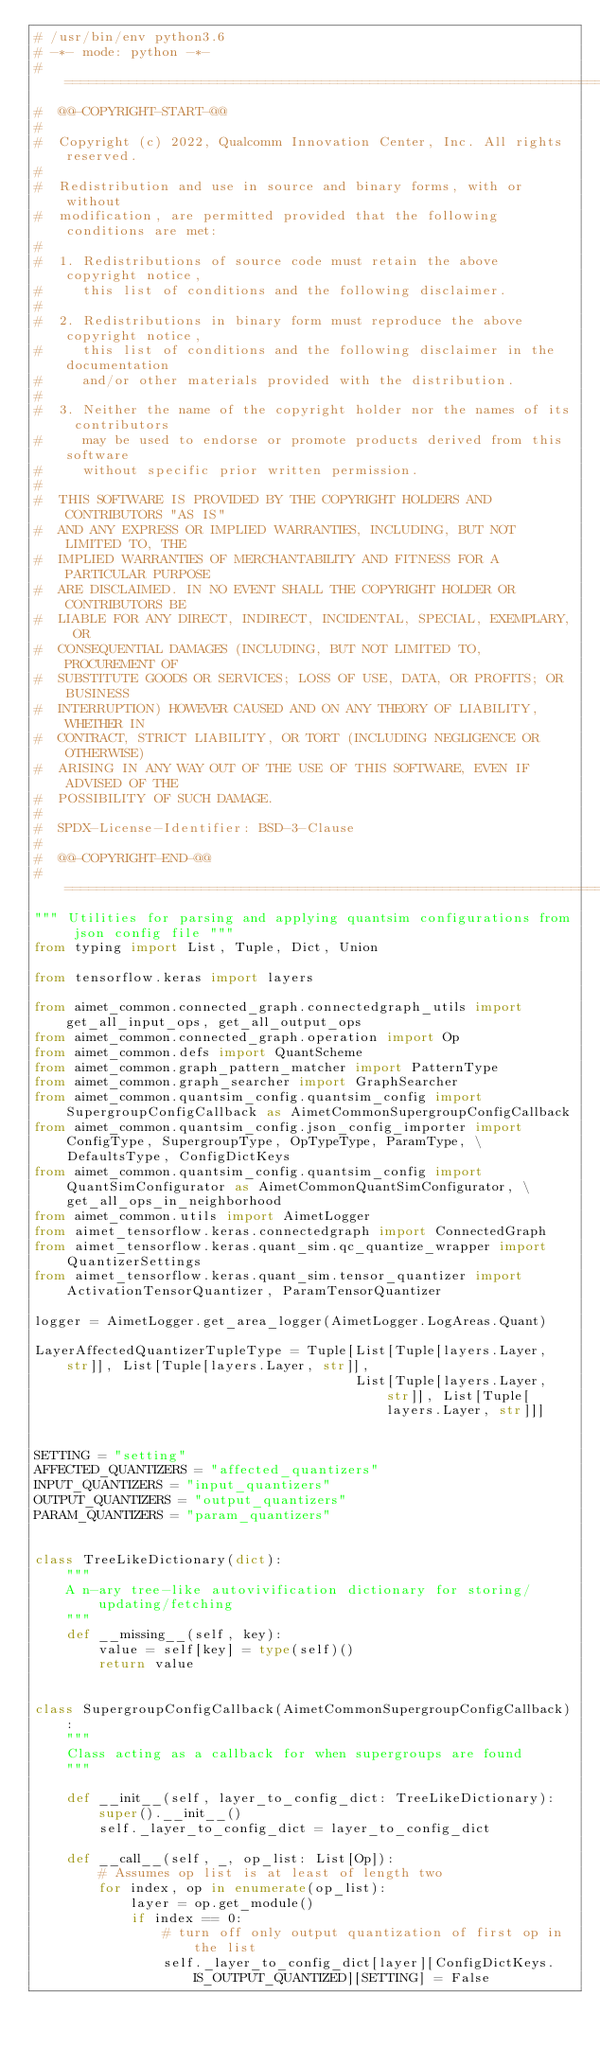<code> <loc_0><loc_0><loc_500><loc_500><_Python_># /usr/bin/env python3.6
# -*- mode: python -*-
# =============================================================================
#  @@-COPYRIGHT-START-@@
#
#  Copyright (c) 2022, Qualcomm Innovation Center, Inc. All rights reserved.
#
#  Redistribution and use in source and binary forms, with or without
#  modification, are permitted provided that the following conditions are met:
#
#  1. Redistributions of source code must retain the above copyright notice,
#     this list of conditions and the following disclaimer.
#
#  2. Redistributions in binary form must reproduce the above copyright notice,
#     this list of conditions and the following disclaimer in the documentation
#     and/or other materials provided with the distribution.
#
#  3. Neither the name of the copyright holder nor the names of its contributors
#     may be used to endorse or promote products derived from this software
#     without specific prior written permission.
#
#  THIS SOFTWARE IS PROVIDED BY THE COPYRIGHT HOLDERS AND CONTRIBUTORS "AS IS"
#  AND ANY EXPRESS OR IMPLIED WARRANTIES, INCLUDING, BUT NOT LIMITED TO, THE
#  IMPLIED WARRANTIES OF MERCHANTABILITY AND FITNESS FOR A PARTICULAR PURPOSE
#  ARE DISCLAIMED. IN NO EVENT SHALL THE COPYRIGHT HOLDER OR CONTRIBUTORS BE
#  LIABLE FOR ANY DIRECT, INDIRECT, INCIDENTAL, SPECIAL, EXEMPLARY, OR
#  CONSEQUENTIAL DAMAGES (INCLUDING, BUT NOT LIMITED TO, PROCUREMENT OF
#  SUBSTITUTE GOODS OR SERVICES; LOSS OF USE, DATA, OR PROFITS; OR BUSINESS
#  INTERRUPTION) HOWEVER CAUSED AND ON ANY THEORY OF LIABILITY, WHETHER IN
#  CONTRACT, STRICT LIABILITY, OR TORT (INCLUDING NEGLIGENCE OR OTHERWISE)
#  ARISING IN ANY WAY OUT OF THE USE OF THIS SOFTWARE, EVEN IF ADVISED OF THE
#  POSSIBILITY OF SUCH DAMAGE.
#
#  SPDX-License-Identifier: BSD-3-Clause
#
#  @@-COPYRIGHT-END-@@
# =============================================================================
""" Utilities for parsing and applying quantsim configurations from json config file """
from typing import List, Tuple, Dict, Union

from tensorflow.keras import layers

from aimet_common.connected_graph.connectedgraph_utils import get_all_input_ops, get_all_output_ops
from aimet_common.connected_graph.operation import Op
from aimet_common.defs import QuantScheme
from aimet_common.graph_pattern_matcher import PatternType
from aimet_common.graph_searcher import GraphSearcher
from aimet_common.quantsim_config.quantsim_config import SupergroupConfigCallback as AimetCommonSupergroupConfigCallback
from aimet_common.quantsim_config.json_config_importer import ConfigType, SupergroupType, OpTypeType, ParamType, \
    DefaultsType, ConfigDictKeys
from aimet_common.quantsim_config.quantsim_config import QuantSimConfigurator as AimetCommonQuantSimConfigurator, \
    get_all_ops_in_neighborhood
from aimet_common.utils import AimetLogger
from aimet_tensorflow.keras.connectedgraph import ConnectedGraph
from aimet_tensorflow.keras.quant_sim.qc_quantize_wrapper import QuantizerSettings
from aimet_tensorflow.keras.quant_sim.tensor_quantizer import ActivationTensorQuantizer, ParamTensorQuantizer

logger = AimetLogger.get_area_logger(AimetLogger.LogAreas.Quant)

LayerAffectedQuantizerTupleType = Tuple[List[Tuple[layers.Layer, str]], List[Tuple[layers.Layer, str]],
                                        List[Tuple[layers.Layer, str]], List[Tuple[layers.Layer, str]]]


SETTING = "setting"
AFFECTED_QUANTIZERS = "affected_quantizers"
INPUT_QUANTIZERS = "input_quantizers"
OUTPUT_QUANTIZERS = "output_quantizers"
PARAM_QUANTIZERS = "param_quantizers"


class TreeLikeDictionary(dict):
    """
    A n-ary tree-like autovivification dictionary for storing/updating/fetching
    """
    def __missing__(self, key):
        value = self[key] = type(self)()
        return value


class SupergroupConfigCallback(AimetCommonSupergroupConfigCallback):
    """
    Class acting as a callback for when supergroups are found
    """

    def __init__(self, layer_to_config_dict: TreeLikeDictionary):
        super().__init__()
        self._layer_to_config_dict = layer_to_config_dict

    def __call__(self, _, op_list: List[Op]):
        # Assumes op list is at least of length two
        for index, op in enumerate(op_list):
            layer = op.get_module()
            if index == 0:
                # turn off only output quantization of first op in the list
                self._layer_to_config_dict[layer][ConfigDictKeys.IS_OUTPUT_QUANTIZED][SETTING] = False</code> 